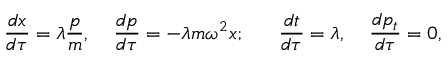Convert formula to latex. <formula><loc_0><loc_0><loc_500><loc_500>{ \frac { d x } { d \tau } } = \lambda { \frac { p } { m } } , \, { \frac { d p } { d \tau } } = - \lambda m \omega ^ { 2 } x ; \, { \frac { d t } { d \tau } } = \lambda , \, { \frac { d p _ { t } } { d \tau } } = 0 ,</formula> 